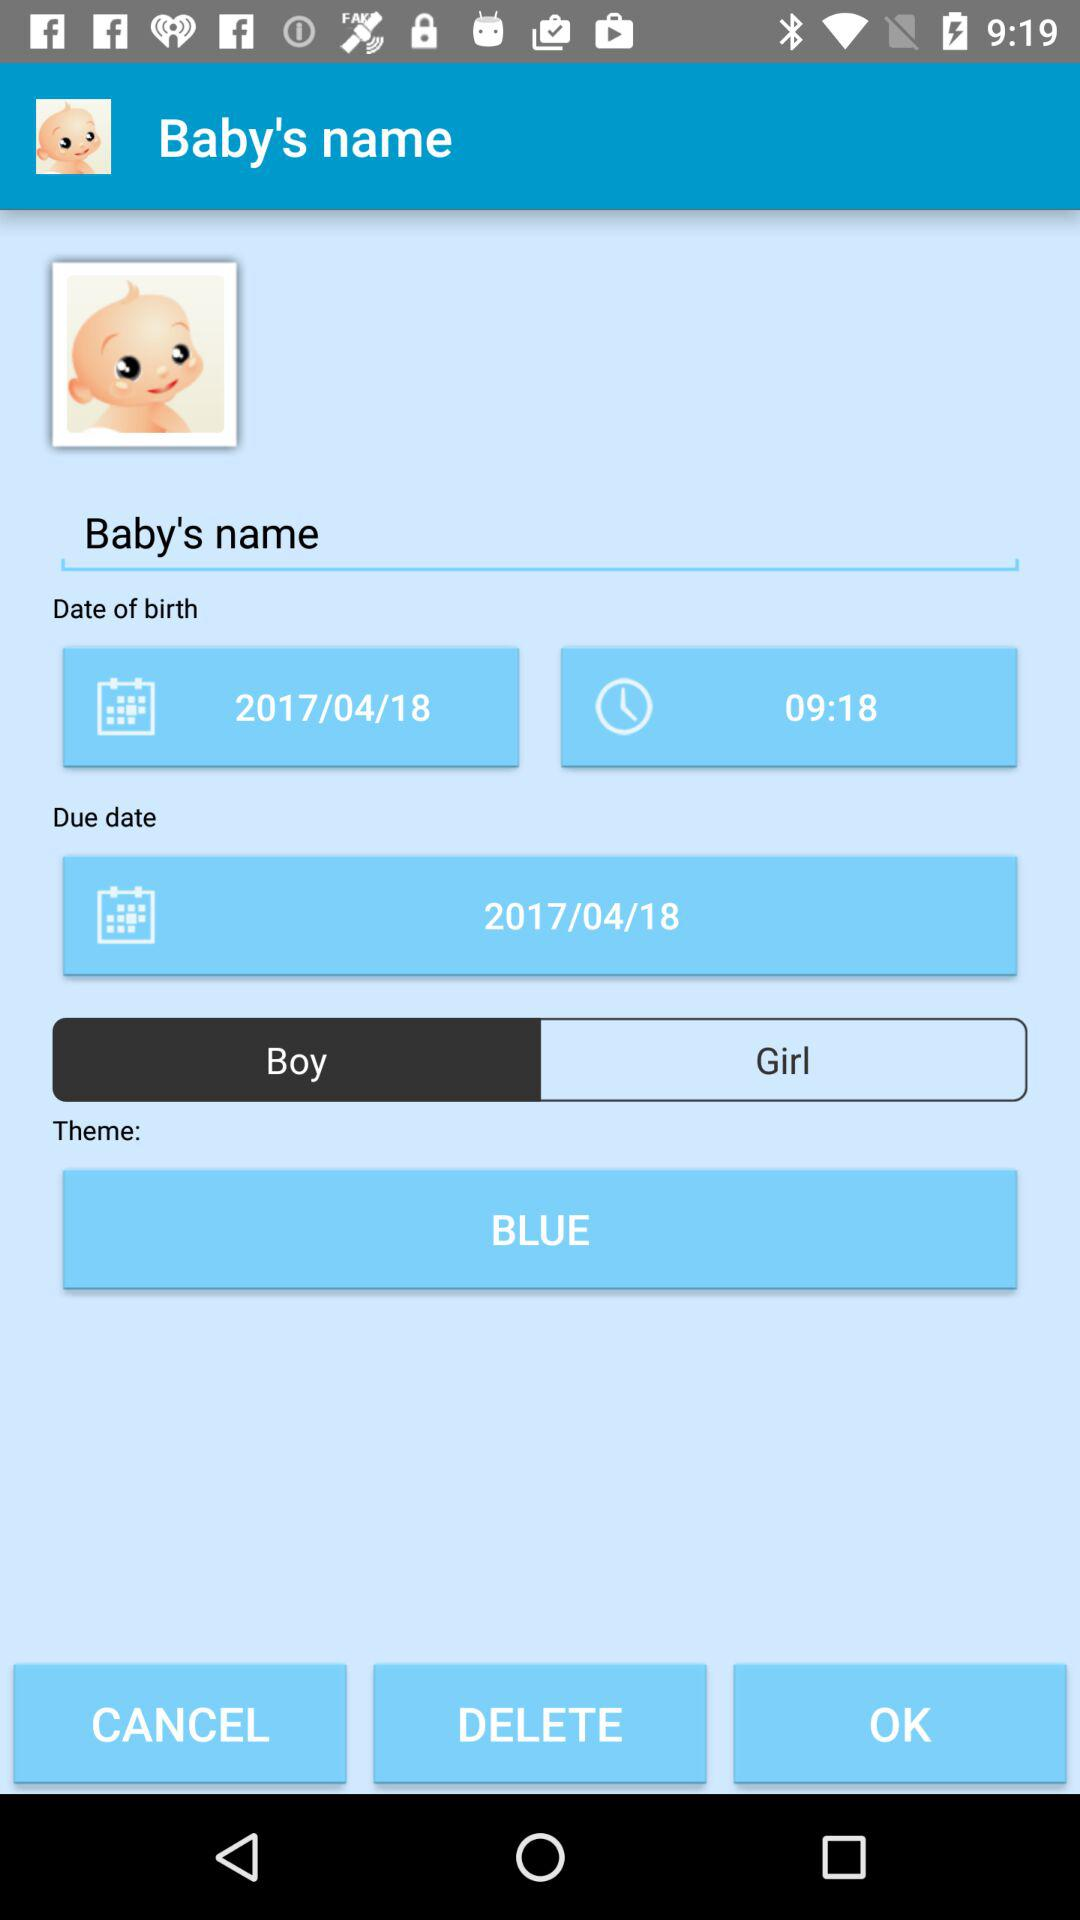What is the selected gender?
Answer the question using a single word or phrase. It's a boy. 